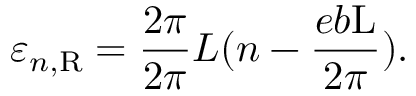Convert formula to latex. <formula><loc_0><loc_0><loc_500><loc_500>\varepsilon _ { n , R } = \frac { 2 \pi } { 2 \pi } { L } ( n - \frac { e b L } { 2 \pi } ) .</formula> 